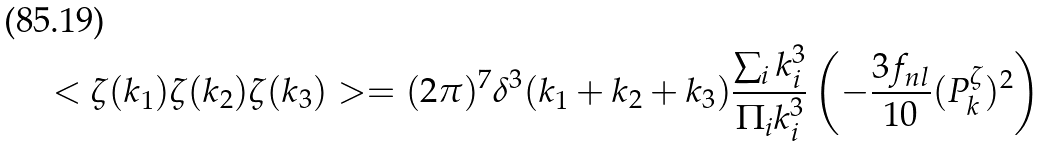<formula> <loc_0><loc_0><loc_500><loc_500>< \zeta ( { k _ { 1 } } ) \zeta ( { k _ { 2 } } ) \zeta ( { k _ { 3 } } ) > = ( 2 \pi ) ^ { 7 } \delta ^ { 3 } ( { k _ { 1 } } + { k _ { 2 } } + { k _ { 3 } } ) \frac { \sum _ { i } k _ { i } ^ { 3 } } { \Pi _ { i } k _ { i } ^ { 3 } } \left ( - \frac { 3 f _ { n l } } { 1 0 } ( P ^ { \zeta } _ { k } ) ^ { 2 } \right )</formula> 